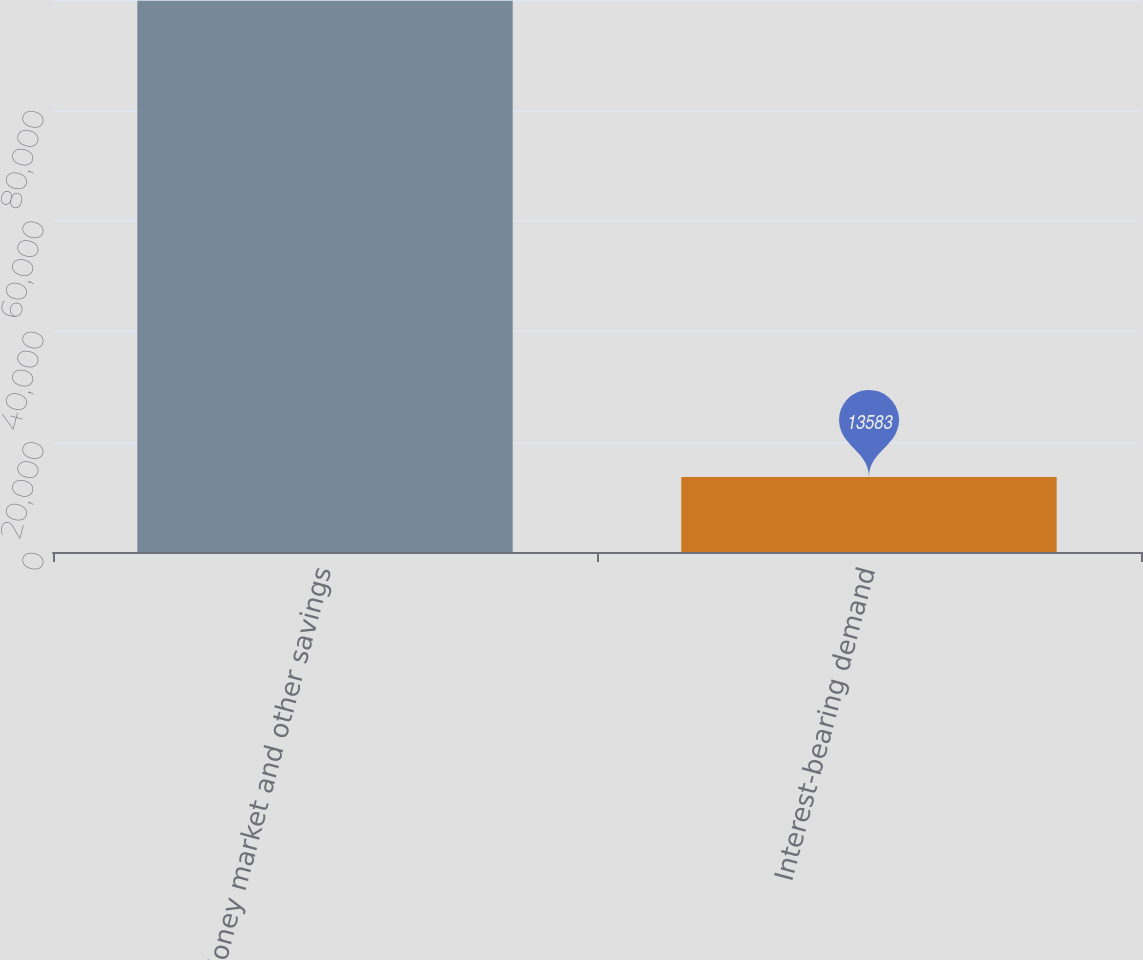Convert chart to OTSL. <chart><loc_0><loc_0><loc_500><loc_500><bar_chart><fcel>Money market and other savings<fcel>Interest-bearing demand<nl><fcel>99881<fcel>13583<nl></chart> 